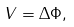<formula> <loc_0><loc_0><loc_500><loc_500>V = \Delta \Phi ,</formula> 